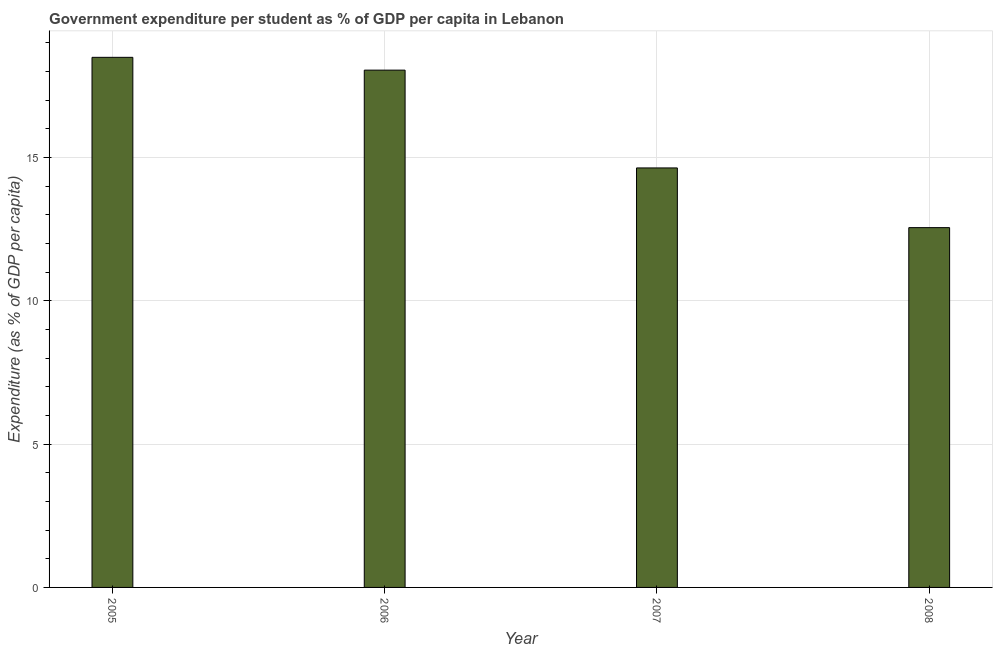Does the graph contain any zero values?
Offer a terse response. No. What is the title of the graph?
Make the answer very short. Government expenditure per student as % of GDP per capita in Lebanon. What is the label or title of the X-axis?
Your answer should be compact. Year. What is the label or title of the Y-axis?
Give a very brief answer. Expenditure (as % of GDP per capita). What is the government expenditure per student in 2007?
Your answer should be very brief. 14.63. Across all years, what is the maximum government expenditure per student?
Ensure brevity in your answer.  18.49. Across all years, what is the minimum government expenditure per student?
Your answer should be very brief. 12.55. In which year was the government expenditure per student maximum?
Your answer should be very brief. 2005. In which year was the government expenditure per student minimum?
Give a very brief answer. 2008. What is the sum of the government expenditure per student?
Keep it short and to the point. 63.72. What is the difference between the government expenditure per student in 2005 and 2006?
Offer a terse response. 0.45. What is the average government expenditure per student per year?
Provide a short and direct response. 15.93. What is the median government expenditure per student?
Your answer should be very brief. 16.34. In how many years, is the government expenditure per student greater than 14 %?
Ensure brevity in your answer.  3. Do a majority of the years between 2006 and 2007 (inclusive) have government expenditure per student greater than 2 %?
Give a very brief answer. Yes. What is the ratio of the government expenditure per student in 2006 to that in 2008?
Offer a terse response. 1.44. Is the difference between the government expenditure per student in 2005 and 2008 greater than the difference between any two years?
Give a very brief answer. Yes. What is the difference between the highest and the second highest government expenditure per student?
Keep it short and to the point. 0.45. Is the sum of the government expenditure per student in 2005 and 2007 greater than the maximum government expenditure per student across all years?
Ensure brevity in your answer.  Yes. What is the difference between the highest and the lowest government expenditure per student?
Provide a short and direct response. 5.94. How many bars are there?
Provide a succinct answer. 4. How many years are there in the graph?
Provide a short and direct response. 4. What is the difference between two consecutive major ticks on the Y-axis?
Make the answer very short. 5. Are the values on the major ticks of Y-axis written in scientific E-notation?
Offer a very short reply. No. What is the Expenditure (as % of GDP per capita) of 2005?
Give a very brief answer. 18.49. What is the Expenditure (as % of GDP per capita) in 2006?
Provide a short and direct response. 18.04. What is the Expenditure (as % of GDP per capita) of 2007?
Offer a very short reply. 14.63. What is the Expenditure (as % of GDP per capita) of 2008?
Keep it short and to the point. 12.55. What is the difference between the Expenditure (as % of GDP per capita) in 2005 and 2006?
Provide a succinct answer. 0.45. What is the difference between the Expenditure (as % of GDP per capita) in 2005 and 2007?
Give a very brief answer. 3.86. What is the difference between the Expenditure (as % of GDP per capita) in 2005 and 2008?
Ensure brevity in your answer.  5.94. What is the difference between the Expenditure (as % of GDP per capita) in 2006 and 2007?
Keep it short and to the point. 3.41. What is the difference between the Expenditure (as % of GDP per capita) in 2006 and 2008?
Keep it short and to the point. 5.49. What is the difference between the Expenditure (as % of GDP per capita) in 2007 and 2008?
Offer a terse response. 2.08. What is the ratio of the Expenditure (as % of GDP per capita) in 2005 to that in 2006?
Provide a short and direct response. 1.02. What is the ratio of the Expenditure (as % of GDP per capita) in 2005 to that in 2007?
Provide a succinct answer. 1.26. What is the ratio of the Expenditure (as % of GDP per capita) in 2005 to that in 2008?
Offer a terse response. 1.47. What is the ratio of the Expenditure (as % of GDP per capita) in 2006 to that in 2007?
Provide a short and direct response. 1.23. What is the ratio of the Expenditure (as % of GDP per capita) in 2006 to that in 2008?
Give a very brief answer. 1.44. What is the ratio of the Expenditure (as % of GDP per capita) in 2007 to that in 2008?
Your answer should be very brief. 1.17. 